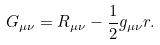Convert formula to latex. <formula><loc_0><loc_0><loc_500><loc_500>G _ { \mu \nu } = R _ { \mu \nu } - \frac { 1 } { 2 } g _ { \mu \nu } r .</formula> 